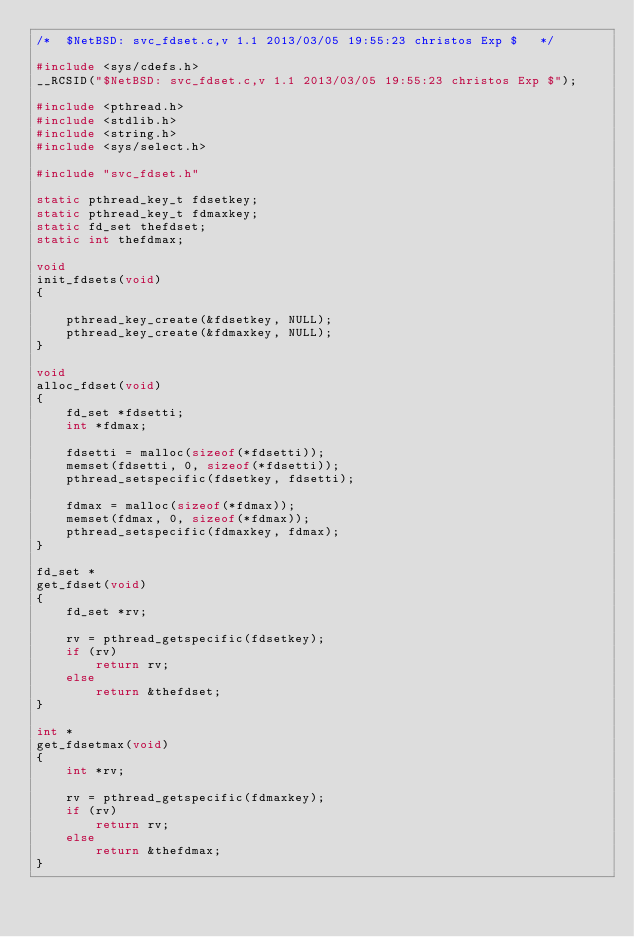Convert code to text. <code><loc_0><loc_0><loc_500><loc_500><_C_>/*	$NetBSD: svc_fdset.c,v 1.1 2013/03/05 19:55:23 christos Exp $	*/

#include <sys/cdefs.h>
__RCSID("$NetBSD: svc_fdset.c,v 1.1 2013/03/05 19:55:23 christos Exp $");

#include <pthread.h>
#include <stdlib.h>
#include <string.h>
#include <sys/select.h>

#include "svc_fdset.h"

static pthread_key_t fdsetkey;
static pthread_key_t fdmaxkey;
static fd_set thefdset;
static int thefdmax;

void
init_fdsets(void)
{

	pthread_key_create(&fdsetkey, NULL);
	pthread_key_create(&fdmaxkey, NULL);
}

void
alloc_fdset(void)
{
	fd_set *fdsetti;
	int *fdmax;

	fdsetti = malloc(sizeof(*fdsetti));
	memset(fdsetti, 0, sizeof(*fdsetti));
	pthread_setspecific(fdsetkey, fdsetti);

	fdmax = malloc(sizeof(*fdmax));
	memset(fdmax, 0, sizeof(*fdmax));
	pthread_setspecific(fdmaxkey, fdmax);
}

fd_set *
get_fdset(void)
{
	fd_set *rv;

	rv = pthread_getspecific(fdsetkey);
	if (rv)
		return rv;
	else
		return &thefdset;
}

int *
get_fdsetmax(void)
{
	int *rv;

	rv = pthread_getspecific(fdmaxkey);
	if (rv)
		return rv;
	else
		return &thefdmax;
}
</code> 